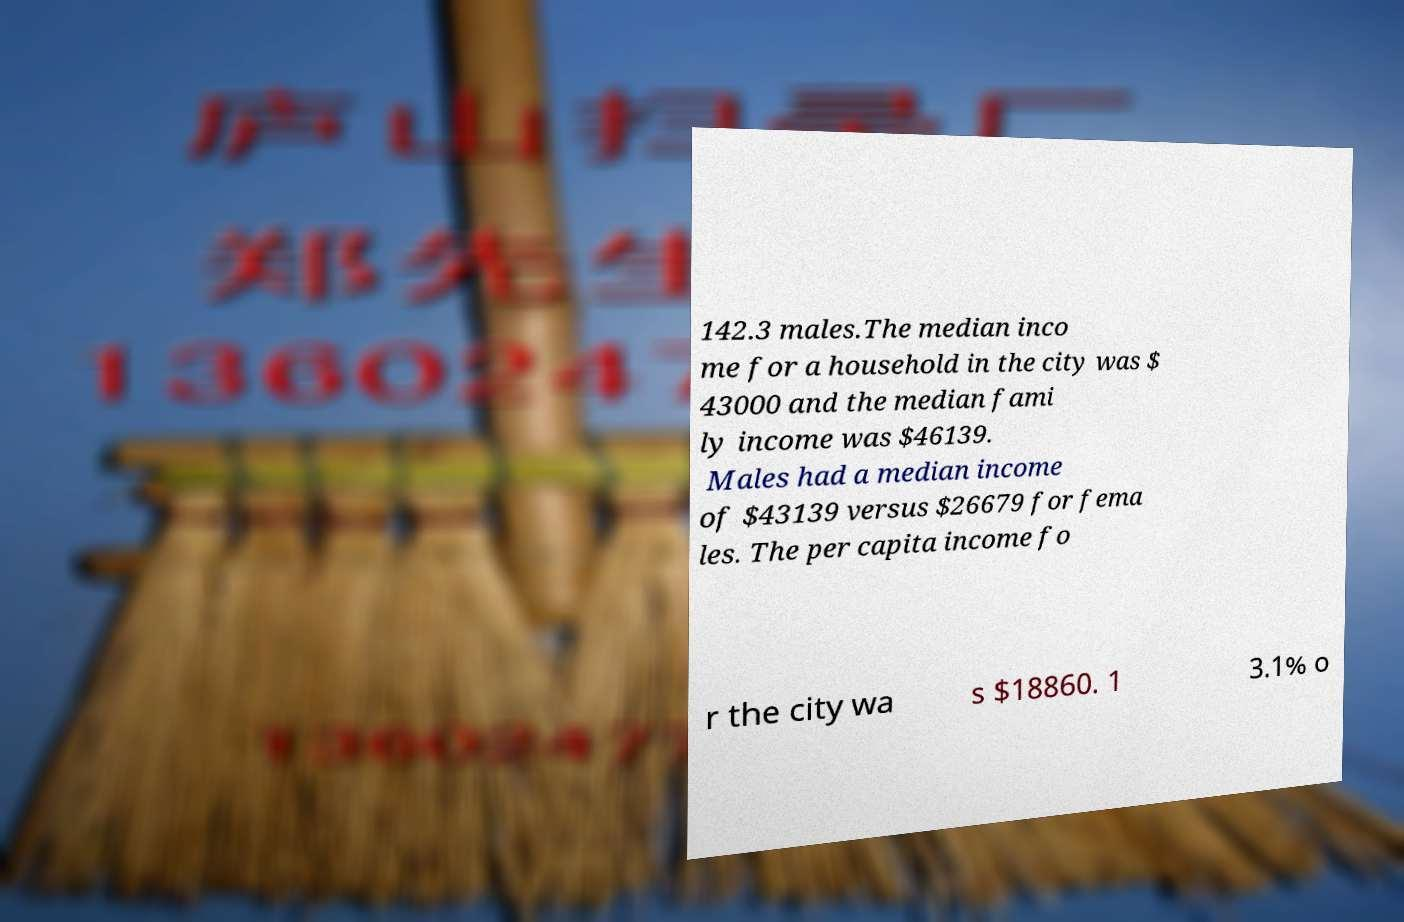Can you read and provide the text displayed in the image?This photo seems to have some interesting text. Can you extract and type it out for me? 142.3 males.The median inco me for a household in the city was $ 43000 and the median fami ly income was $46139. Males had a median income of $43139 versus $26679 for fema les. The per capita income fo r the city wa s $18860. 1 3.1% o 